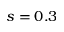Convert formula to latex. <formula><loc_0><loc_0><loc_500><loc_500>s = 0 . 3</formula> 